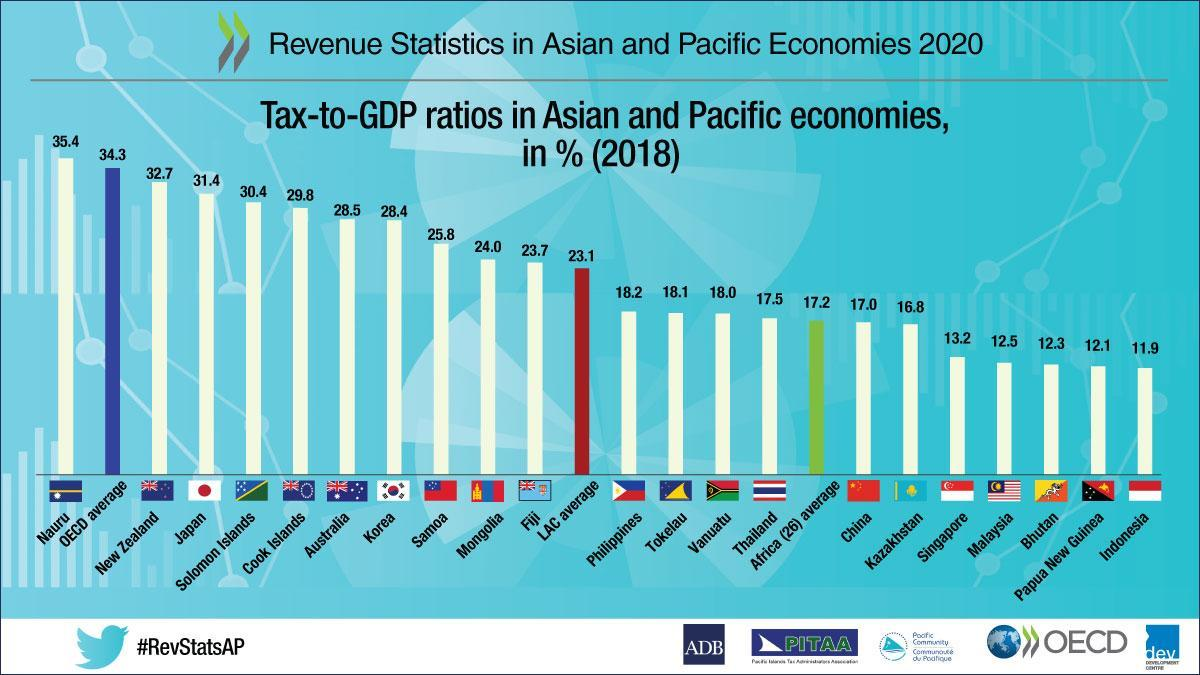Which colour is used to indicate OECD average- red, green or blue?
Answer the question with a short phrase. Blue What is the tax-to-GDP ratio of Tokelau? 18.1 After Nauru, which economy has the highest tax-to-GDP ratio? New Zealand Which economy has the lowest tax-to-GDP ratio? Indonesia Which country has Tax-to-GDP ratios equal to 25.8? Samoa What does the red coloured bar indicate? LAC average What is the tax-to-GDP ratio of seventh economy from left excluding OECD average? 28.4 